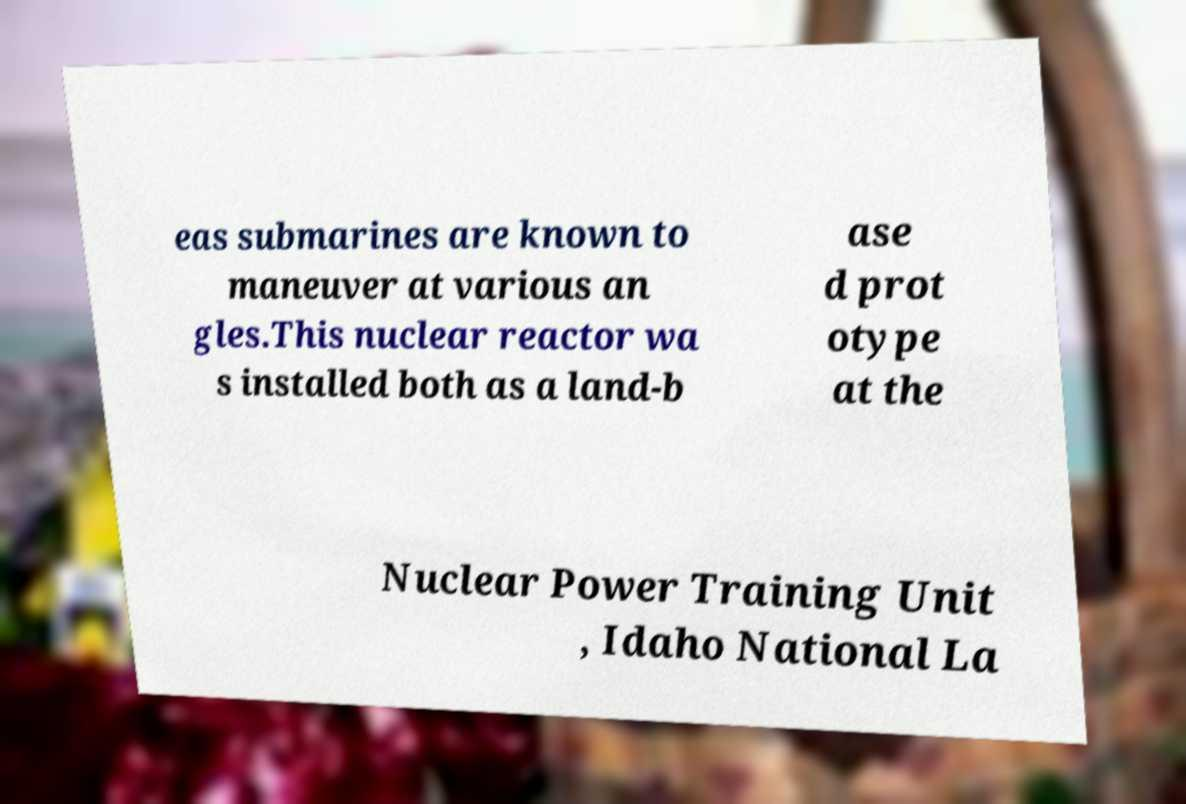Can you accurately transcribe the text from the provided image for me? eas submarines are known to maneuver at various an gles.This nuclear reactor wa s installed both as a land-b ase d prot otype at the Nuclear Power Training Unit , Idaho National La 